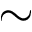<formula> <loc_0><loc_0><loc_500><loc_500>\sim</formula> 